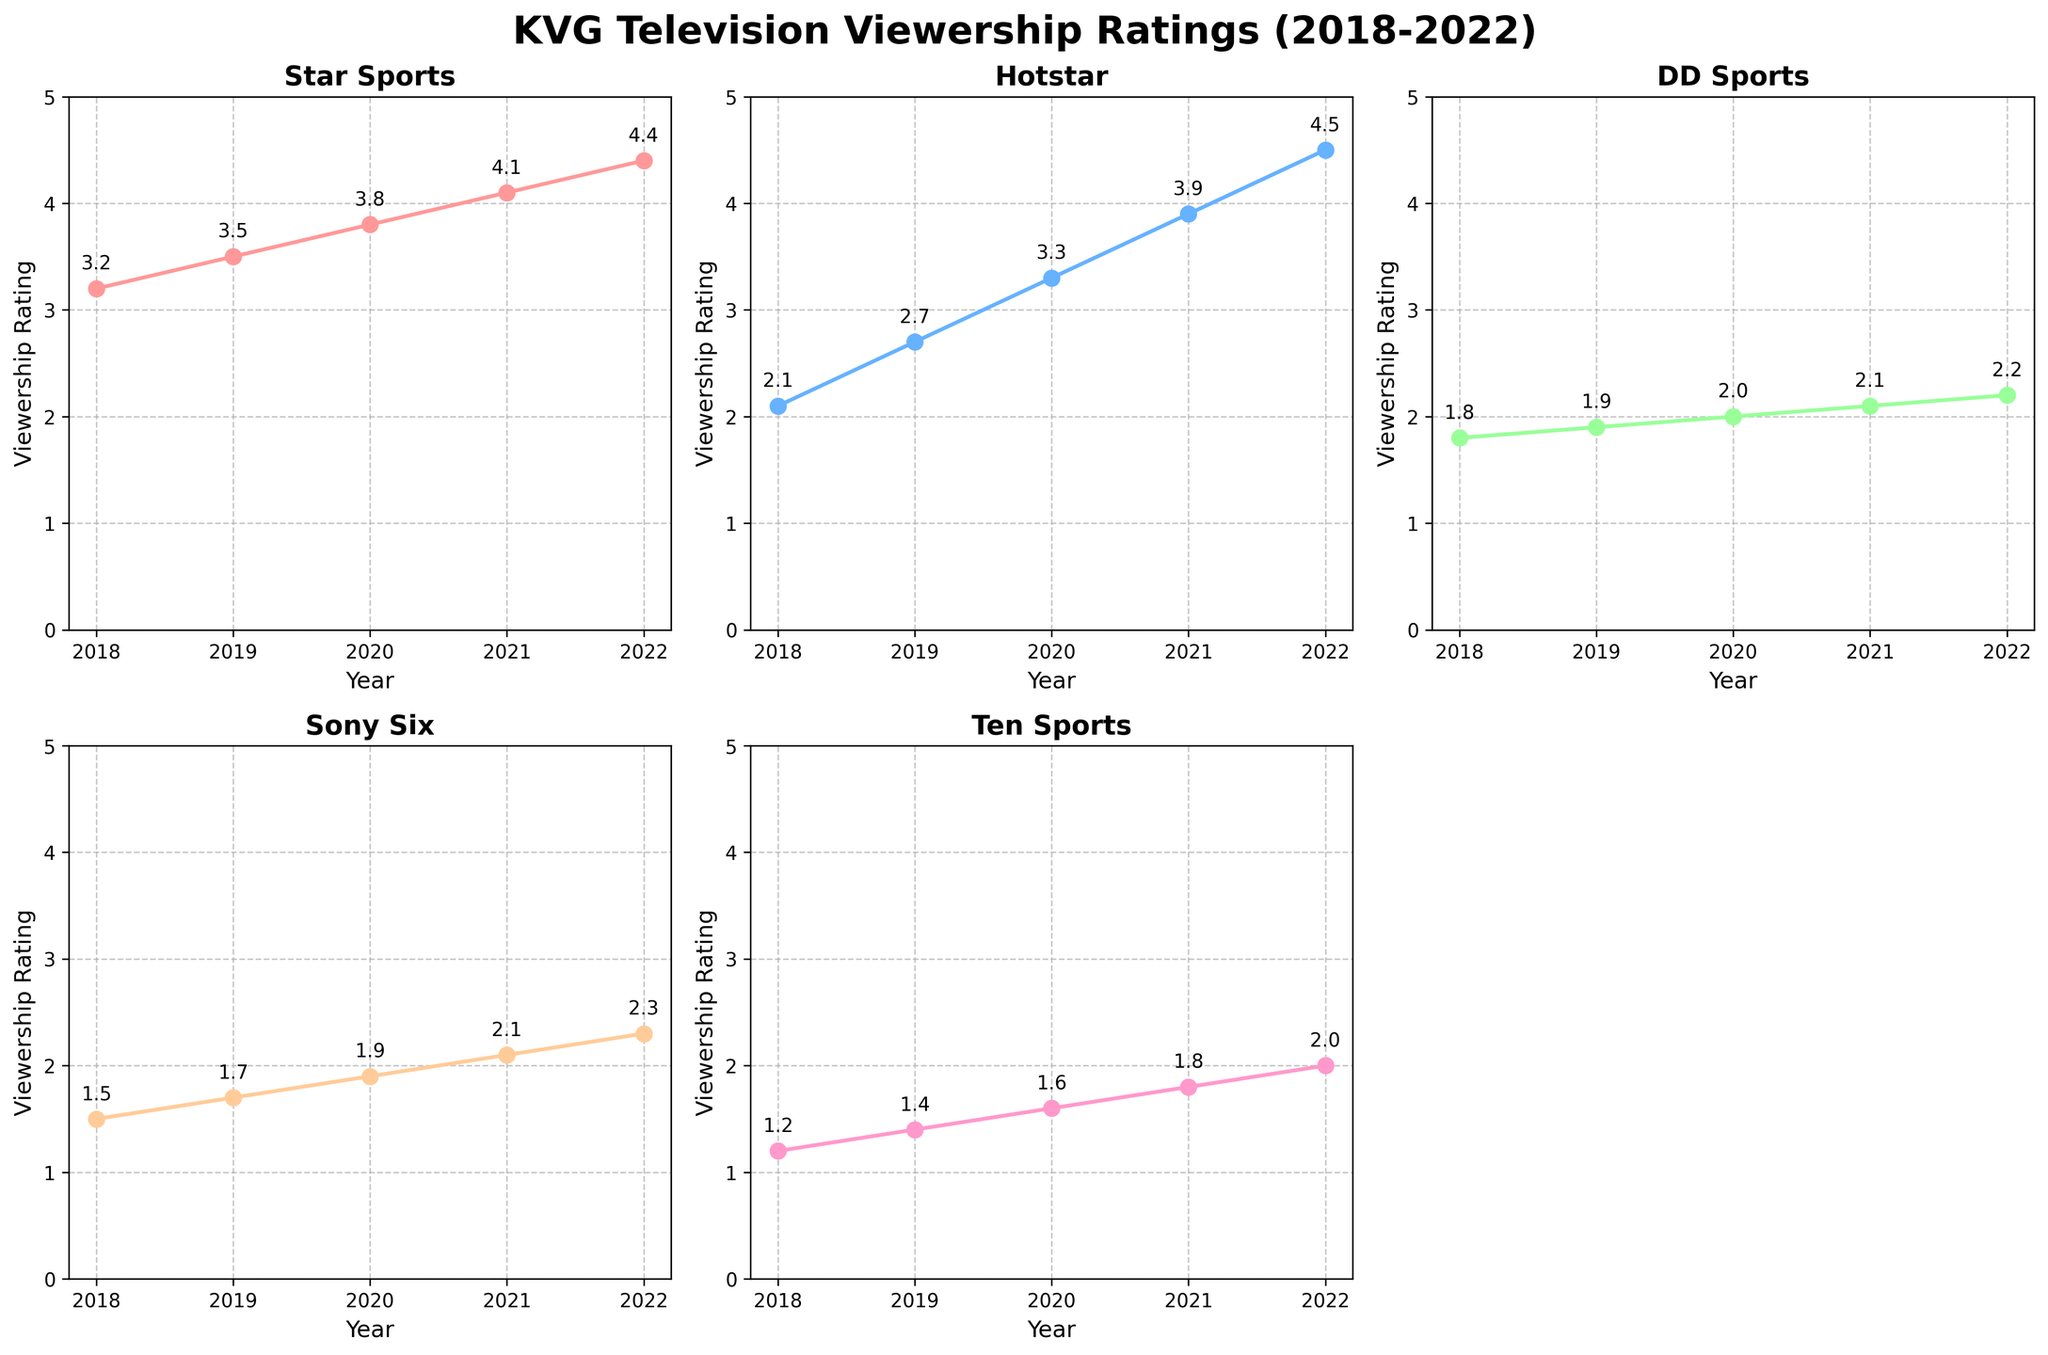What is the viewership rating for Star Sports in 2020? The subplot for Star Sports shows the viewership ratings for each year. Locate the data point for 2020 on the x-axis and read the corresponding y-axis value.
Answer: 3.8 Which platform had the highest viewership rating in 2022? Compare the final data points in the subplots for each platform. Identify the one with the highest y-axis value in 2022.
Answer: Hotstar How does the increase in viewership from 2018 to 2022 for DD Sports compare to that for Sony Six? Subtract the 2018 viewership rating from the 2022 rating for both DD Sports and Sony Six, and compare the differences. DD Sports: 2.2-1.8=0.4; Sony Six: 2.3-1.5=0.8
Answer: Sony Six What is the average viewership rating for Hotstar across the five years? Add the viewership ratings for Hotstar over the five years (2018:2.1, 2019:2.7, 2020:3.3, 2021:3.9, 2022:4.5) and divide by the number of years (5). (2.1+2.7+3.3+3.9+4.5)/5=3.3
Answer: 3.3 Which platform had the least viewership growth from 2018 to 2022? Calculate the difference in ratings from 2018 to 2022 for all platforms and identify the smallest difference: Star Sports: 4.4-3.2=1.2; Hotstar: 4.5-2.1=2.4; DD Sports: 2.2-1.8=0.4; Sony Six: 2.3-1.5=0.8; Ten Sports: 2.0-1.2=0.8.
Answer: DD Sports Did any platform see a decrease in viewership ratings at any point between 2018 and 2022? Look at the ratings for each platform year by year. Check if any platform has a lower rating in a subsequent year compared to the previous year.
Answer: No What is the combined viewership rating for all platforms in 2019? Sum the 2019 viewership ratings for all platforms: Star Sports: 3.5, Hotstar: 2.7, DD Sports: 1.9, Sony Six: 1.7, Ten Sports: 1.4. (3.5+2.7+1.9+1.7+1.4)=11.2
Answer: 11.2 